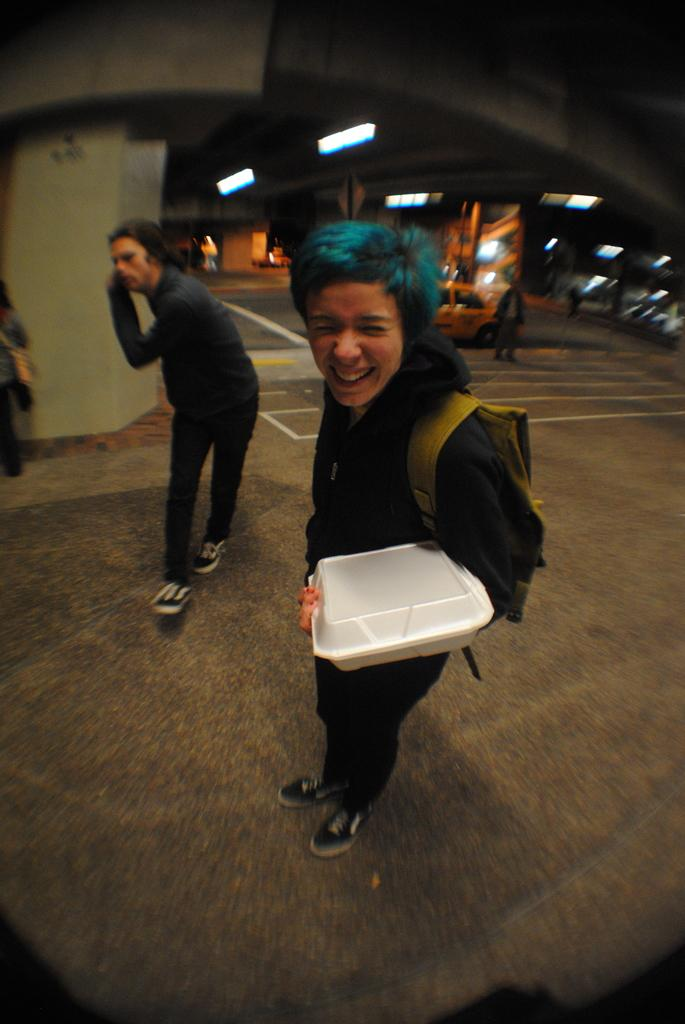What is happening in the image? There are people on the road in the image. What is the person holding in the image? A person is holding an object in the image. What can be seen in the background of the image? There is a car and lights attached to the ceiling in the background of the image. What type of book is being distributed by the person in the image? There is no book present in the image, and no distribution is taking place. 